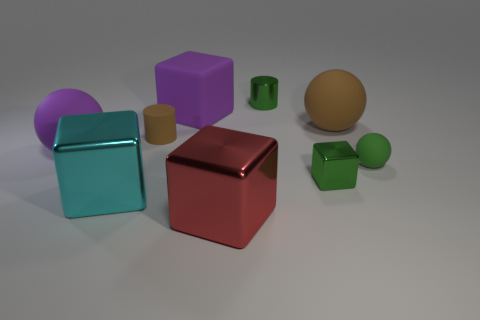How many large blue rubber cubes are there?
Keep it short and to the point. 0. The thing that is both in front of the tiny brown cylinder and behind the small ball has what shape?
Your answer should be compact. Sphere. What is the shape of the matte thing that is left of the tiny cylinder that is on the left side of the tiny green thing that is on the left side of the tiny block?
Offer a terse response. Sphere. There is a big cube that is both on the right side of the large cyan thing and behind the big red cube; what material is it?
Offer a very short reply. Rubber. How many red matte spheres have the same size as the cyan cube?
Your answer should be very brief. 0. How many shiny objects are big blue balls or green things?
Provide a short and direct response. 2. What is the large brown object made of?
Make the answer very short. Rubber. What number of purple objects are in front of the small rubber cylinder?
Provide a short and direct response. 1. Is the green thing that is behind the small green matte thing made of the same material as the cyan block?
Give a very brief answer. Yes. What number of green things have the same shape as the big brown thing?
Offer a very short reply. 1. 